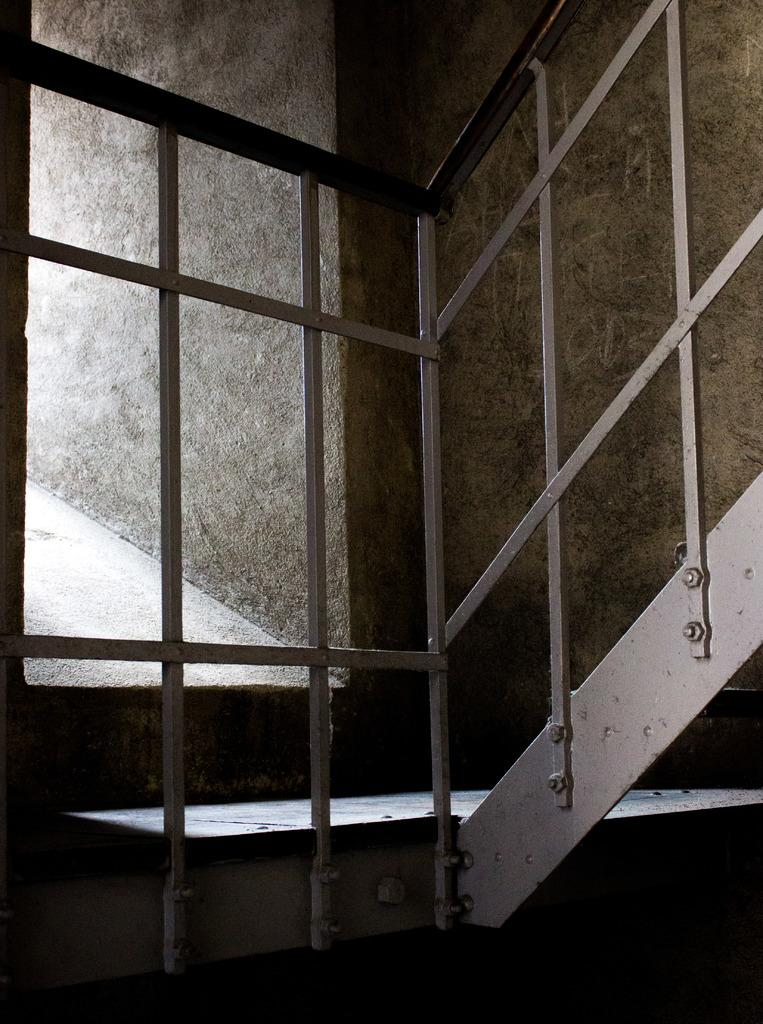What type of stairs are visible in the image? There are iron stairs in the image. What can be seen in the background of the image? There is a wall in the background of the image. What type of mist is present around the iron stairs in the image? There is no mist present in the image; it is a clear image of iron stairs and a wall. 